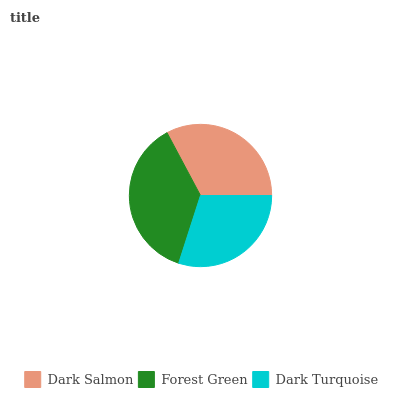Is Dark Turquoise the minimum?
Answer yes or no. Yes. Is Forest Green the maximum?
Answer yes or no. Yes. Is Forest Green the minimum?
Answer yes or no. No. Is Dark Turquoise the maximum?
Answer yes or no. No. Is Forest Green greater than Dark Turquoise?
Answer yes or no. Yes. Is Dark Turquoise less than Forest Green?
Answer yes or no. Yes. Is Dark Turquoise greater than Forest Green?
Answer yes or no. No. Is Forest Green less than Dark Turquoise?
Answer yes or no. No. Is Dark Salmon the high median?
Answer yes or no. Yes. Is Dark Salmon the low median?
Answer yes or no. Yes. Is Dark Turquoise the high median?
Answer yes or no. No. Is Dark Turquoise the low median?
Answer yes or no. No. 